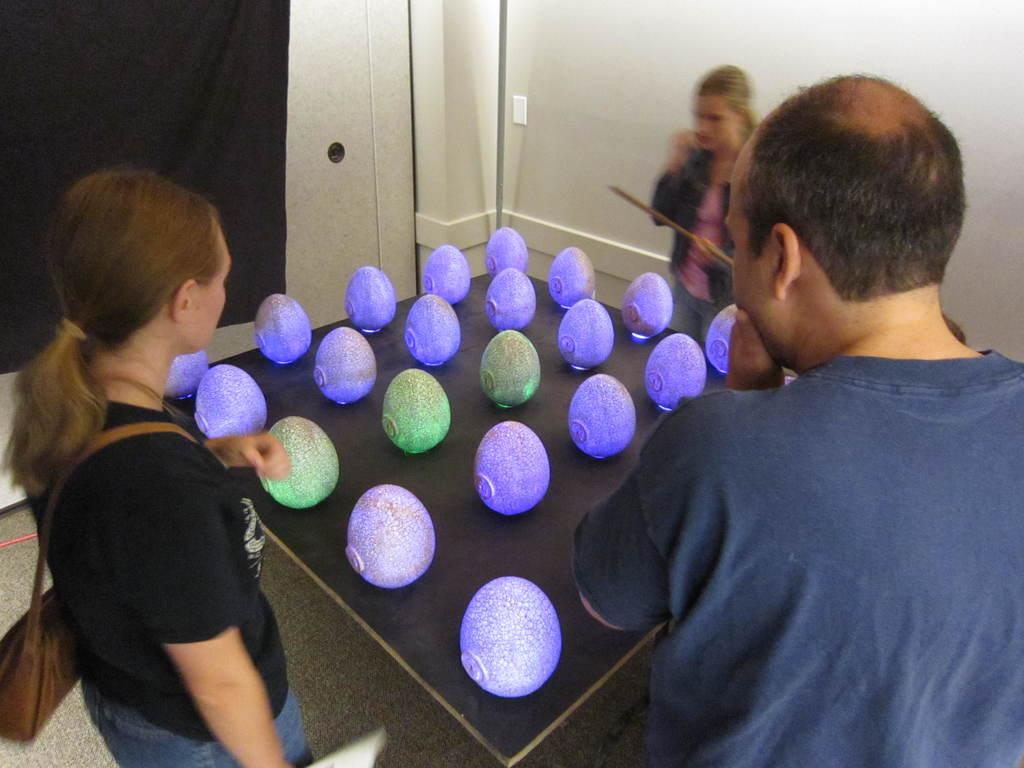How many people are in the image? There are two women and a man in the image. What is the position of the people in the image? The people are standing on the floor. What can be seen on the table in front of the people? There are objects on a table in front of the people. What is visible in the background of the image? There is a cloth and a wall in the background of the image. What is the name of the star that the man is holding in the image? There is no star present in the image; the people are standing on the floor with objects on a table in front of them. 